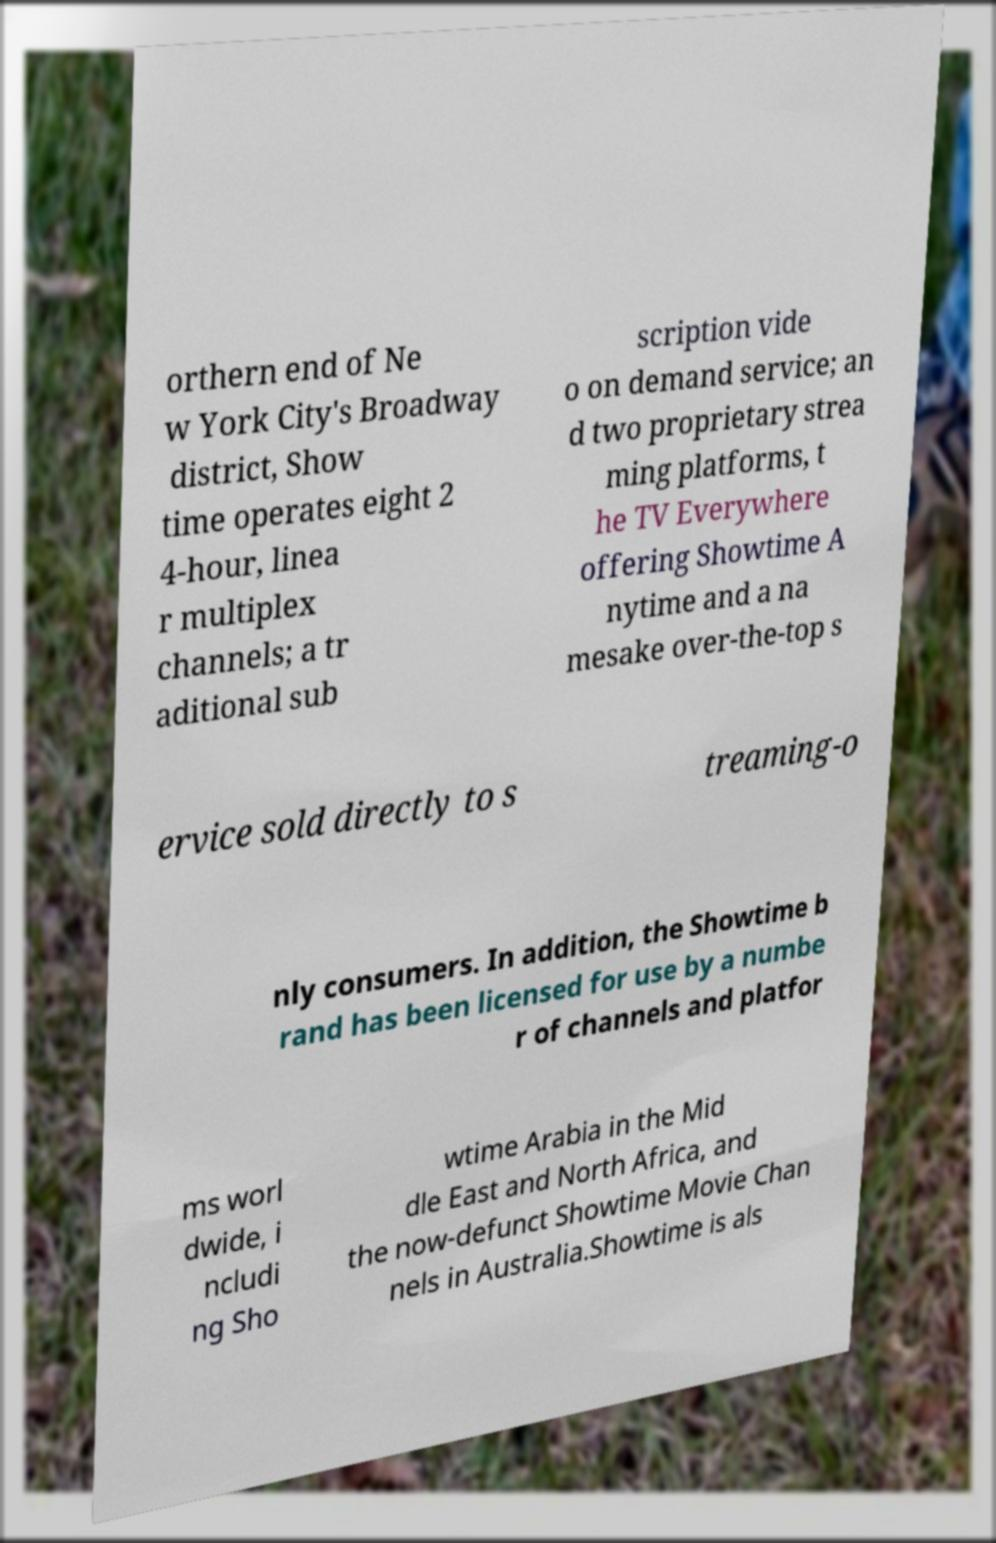Please identify and transcribe the text found in this image. orthern end of Ne w York City's Broadway district, Show time operates eight 2 4-hour, linea r multiplex channels; a tr aditional sub scription vide o on demand service; an d two proprietary strea ming platforms, t he TV Everywhere offering Showtime A nytime and a na mesake over-the-top s ervice sold directly to s treaming-o nly consumers. In addition, the Showtime b rand has been licensed for use by a numbe r of channels and platfor ms worl dwide, i ncludi ng Sho wtime Arabia in the Mid dle East and North Africa, and the now-defunct Showtime Movie Chan nels in Australia.Showtime is als 